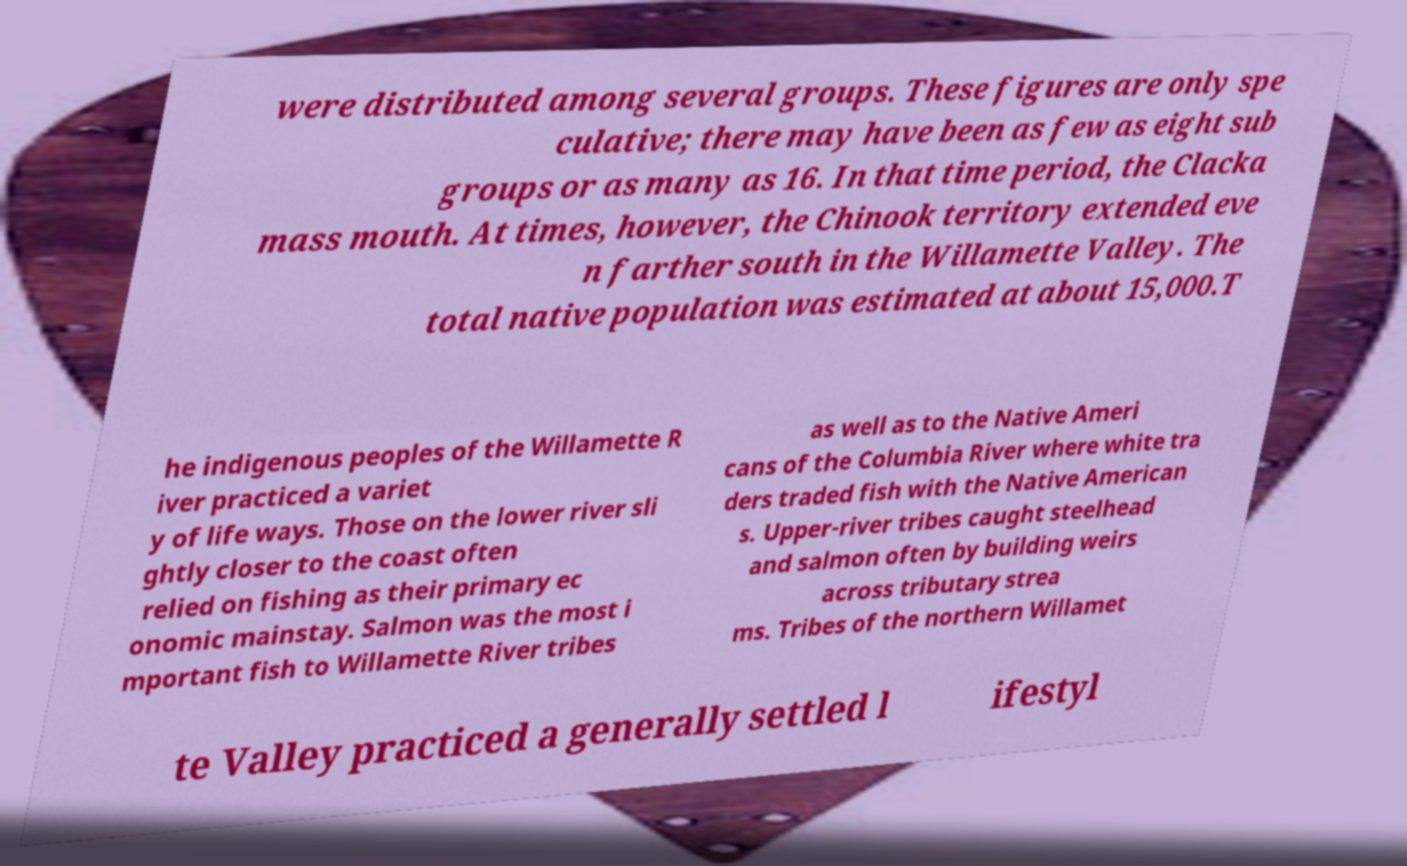Can you read and provide the text displayed in the image?This photo seems to have some interesting text. Can you extract and type it out for me? were distributed among several groups. These figures are only spe culative; there may have been as few as eight sub groups or as many as 16. In that time period, the Clacka mass mouth. At times, however, the Chinook territory extended eve n farther south in the Willamette Valley. The total native population was estimated at about 15,000.T he indigenous peoples of the Willamette R iver practiced a variet y of life ways. Those on the lower river sli ghtly closer to the coast often relied on fishing as their primary ec onomic mainstay. Salmon was the most i mportant fish to Willamette River tribes as well as to the Native Ameri cans of the Columbia River where white tra ders traded fish with the Native American s. Upper-river tribes caught steelhead and salmon often by building weirs across tributary strea ms. Tribes of the northern Willamet te Valley practiced a generally settled l ifestyl 